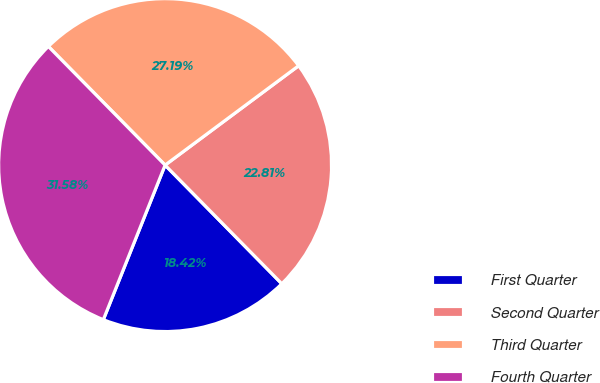Convert chart. <chart><loc_0><loc_0><loc_500><loc_500><pie_chart><fcel>First Quarter<fcel>Second Quarter<fcel>Third Quarter<fcel>Fourth Quarter<nl><fcel>18.42%<fcel>22.81%<fcel>27.19%<fcel>31.58%<nl></chart> 